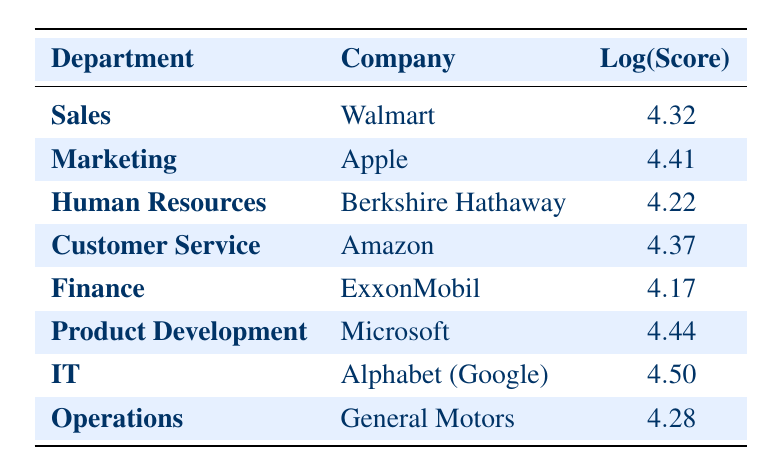What is the Employee Engagement Score for the IT department at Alphabet (Google)? The table lists a specific Engagement Score for each department. Looking under the IT department, the score is clearly listed as 90.
Answer: 90 Which department at Amazon has an Employee Engagement Score? According to the table, we can see Amazon is associated with the Customer Service department, which lists an Engagement Score of 79.
Answer: Customer Service What is the highest Engagement Score among the listed departments? By examining the scores, we see that the highest value is for the IT department with a score of 90.
Answer: 90 Calculate the average Engagement Score of the Sales, Marketing, and Customer Service departments. The scores for these departments are: Sales (75), Marketing (82), Customer Service (79). Adding them gives 75 + 82 + 79 = 236. There are 3 departments, so the average is 236 / 3 = 78.67.
Answer: 78.67 Is the Employee Engagement Score for Finance higher than that of Human Resources? The Finance department has a score of 65 while Human Resources has a score of 68. Since 65 is less than 68, the statement is false.
Answer: No Which department shows the greatest difference in Engagement Score compared to the IT department? The scores are: IT (90), Sales (75), Marketing (82), Customer Service (79), Human Resources (68), Finance (65), Product Development (85), Operations (72). The largest difference is between IT (90) and Finance (65), a difference of 25.
Answer: Finance Is there a department with an Engagement Score of 80 or more? By reviewing the table, we find that Marketing (82), Product Development (85), and IT (90) all have scores exceeding 80. Therefore, the answer is yes.
Answer: Yes What is the Engagement Score of the Product Development department compared to the average Engagement Score of all departments? The Product Development department's score is 85. To find the average of all scores (75 + 82 + 68 + 79 + 65 + 85 + 90 + 72 = 72.5 / 8 = 76.75), comparing gives us that 85 is higher than 76.75.
Answer: Higher Which department has the lowest Engagement Score, and what is that score? Inspecting the scores provided, we find that Finance has the lowest score of 65.
Answer: Finance, 65 